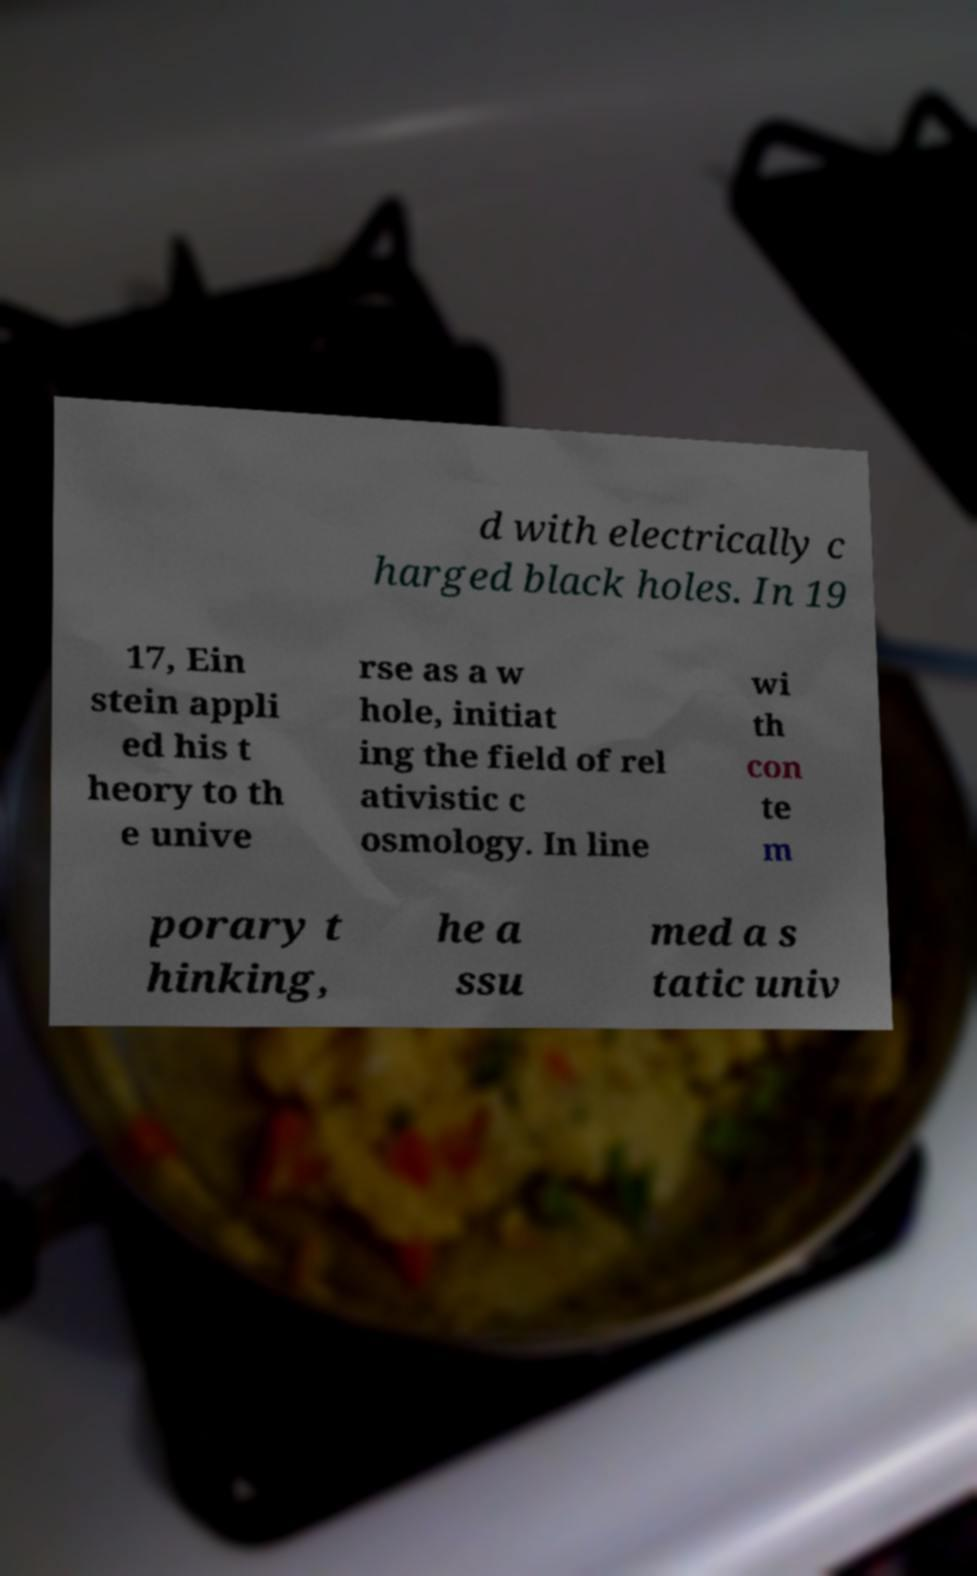Can you read and provide the text displayed in the image?This photo seems to have some interesting text. Can you extract and type it out for me? d with electrically c harged black holes. In 19 17, Ein stein appli ed his t heory to th e unive rse as a w hole, initiat ing the field of rel ativistic c osmology. In line wi th con te m porary t hinking, he a ssu med a s tatic univ 